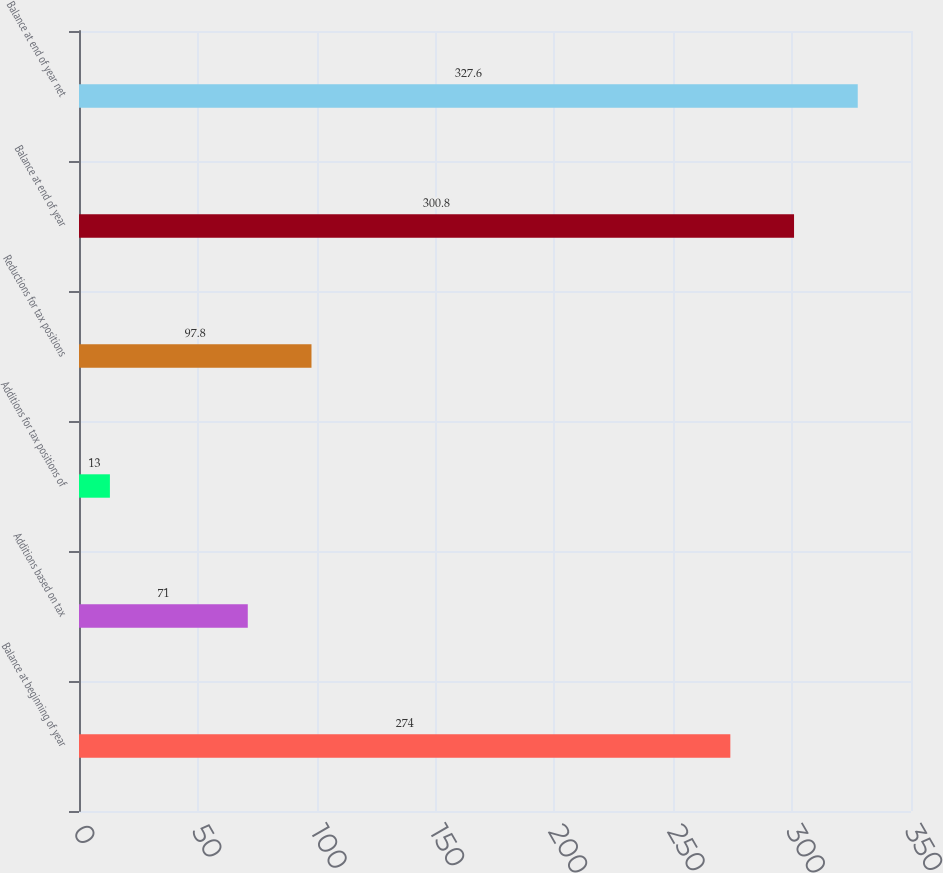Convert chart to OTSL. <chart><loc_0><loc_0><loc_500><loc_500><bar_chart><fcel>Balance at beginning of year<fcel>Additions based on tax<fcel>Additions for tax positions of<fcel>Reductions for tax positions<fcel>Balance at end of year<fcel>Balance at end of year net<nl><fcel>274<fcel>71<fcel>13<fcel>97.8<fcel>300.8<fcel>327.6<nl></chart> 